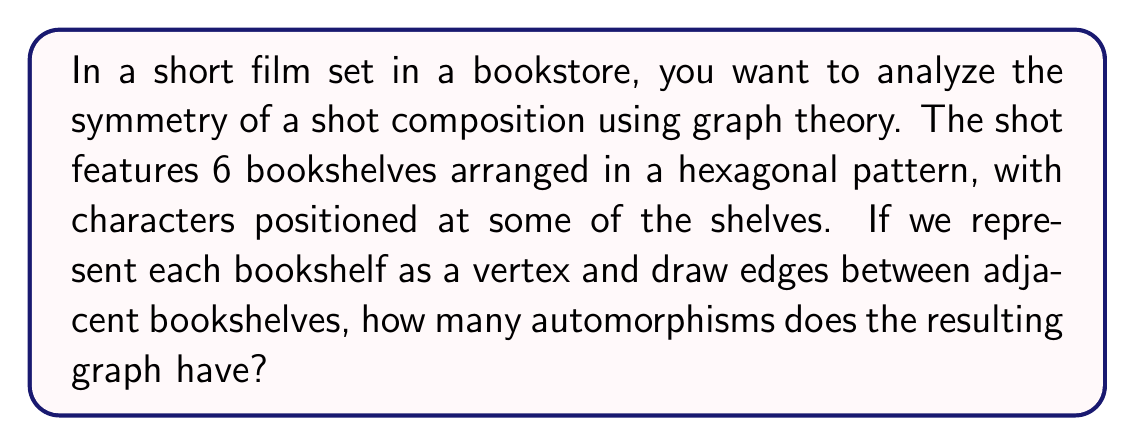Provide a solution to this math problem. To solve this problem, we need to follow these steps:

1) First, let's visualize the graph:

[asy]
unitsize(2cm);
pair[] vertices = {dir(0), dir(60), dir(120), dir(180), dir(240), dir(300)};
for(int i = 0; i < 6; ++i)
  draw(vertices[i]--vertices[(i+1)%6]);
for(int i = 0; i < 6; ++i)
  dot(vertices[i]);
[/asy]

2) This graph is known as a cycle graph on 6 vertices, denoted as $C_6$.

3) The automorphisms of a graph are the symmetries that preserve the graph structure. For a cycle graph, these are:
   - Rotations: We can rotate the graph by any multiple of 60° (as there are 6 vertices).
   - Reflections: We can reflect the graph across any of its axes of symmetry.

4) For $C_6$, we have:
   - 6 rotations (including the identity rotation of 0°)
   - 6 reflections (3 across diameters and 3 across lines between opposite vertices)

5) The total number of automorphisms is the sum of rotations and reflections:

   $$ \text{Total automorphisms} = \text{Rotations} + \text{Reflections} = 6 + 6 = 12 $$

6) This number can also be derived from the dihedral group $D_6$, which is the symmetry group of a regular hexagon. The order of $D_n$ is always $2n$, where $n$ is the number of sides.

   $$ |D_6| = 2 \cdot 6 = 12 $$

Therefore, the graph representing the bookshelf arrangement has 12 automorphisms.
Answer: 12 automorphisms 